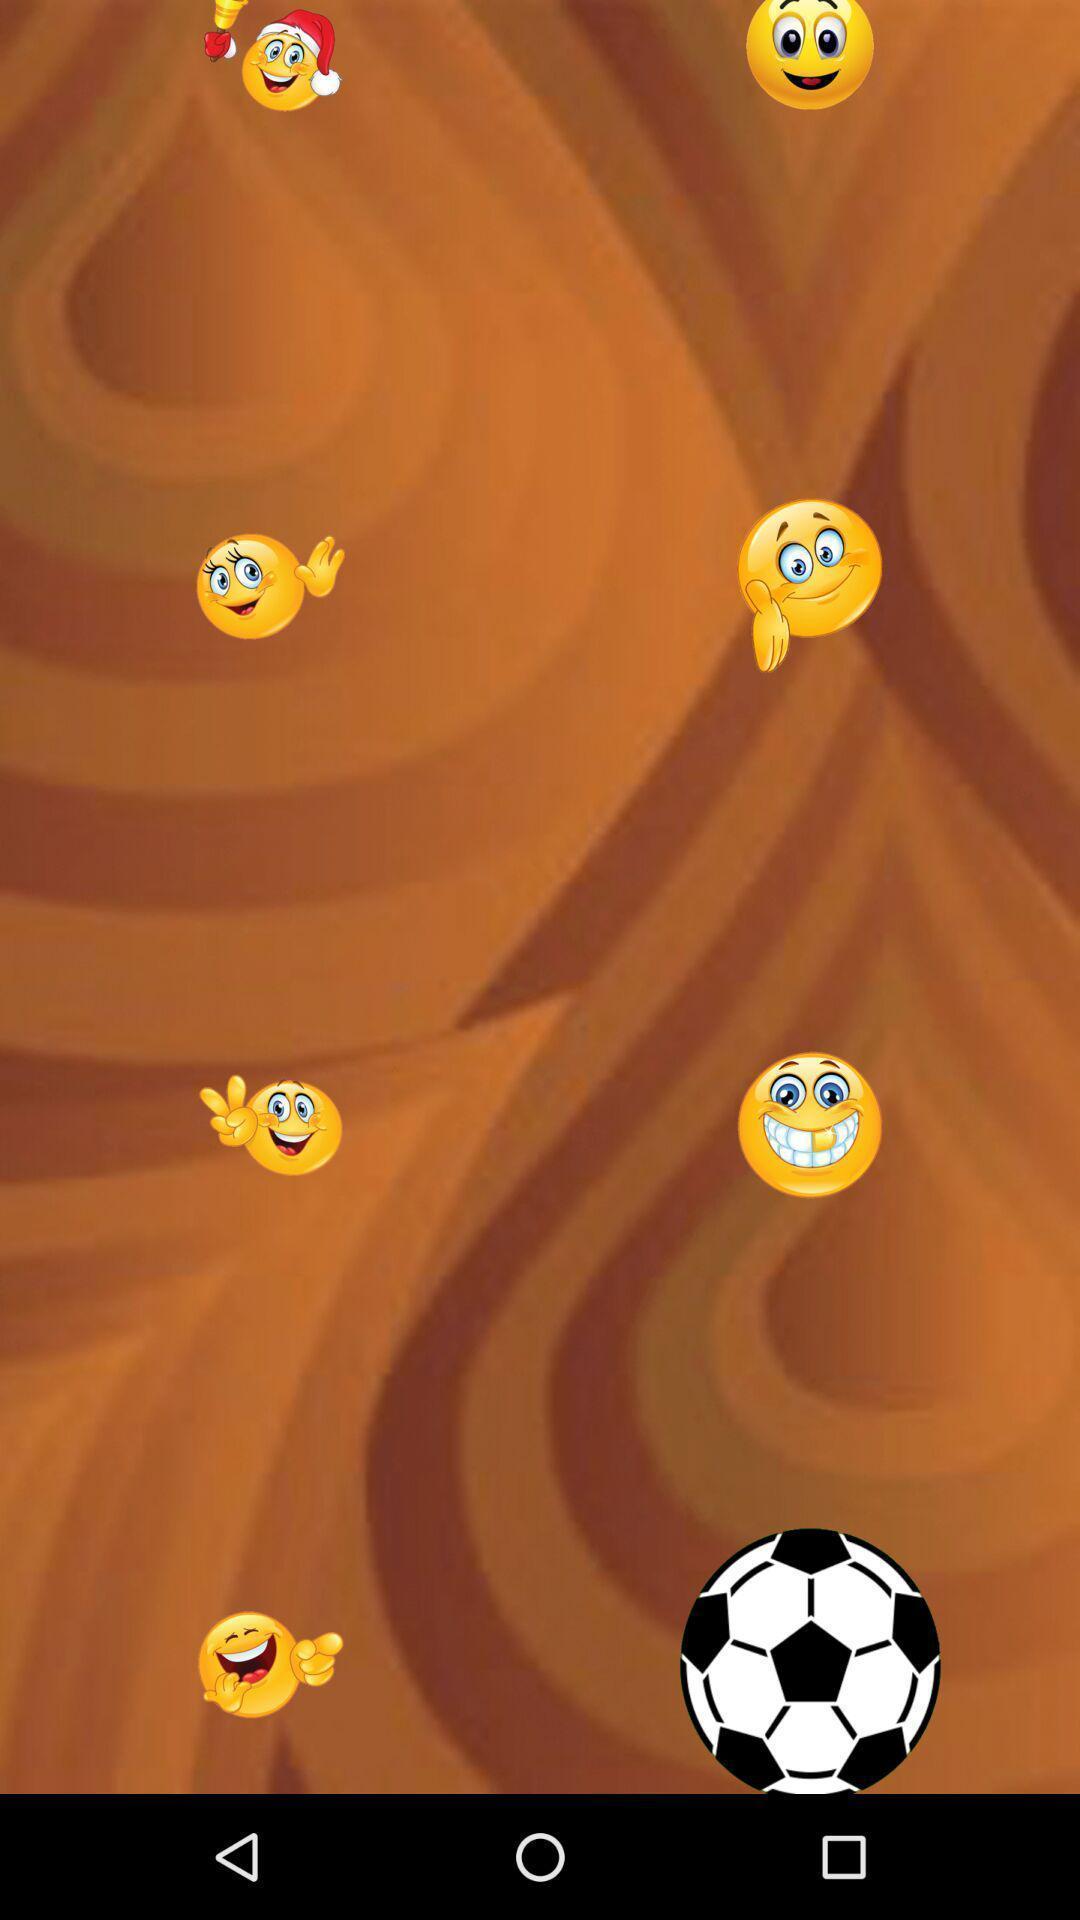Describe the content in this image. Screen showing stickers. 